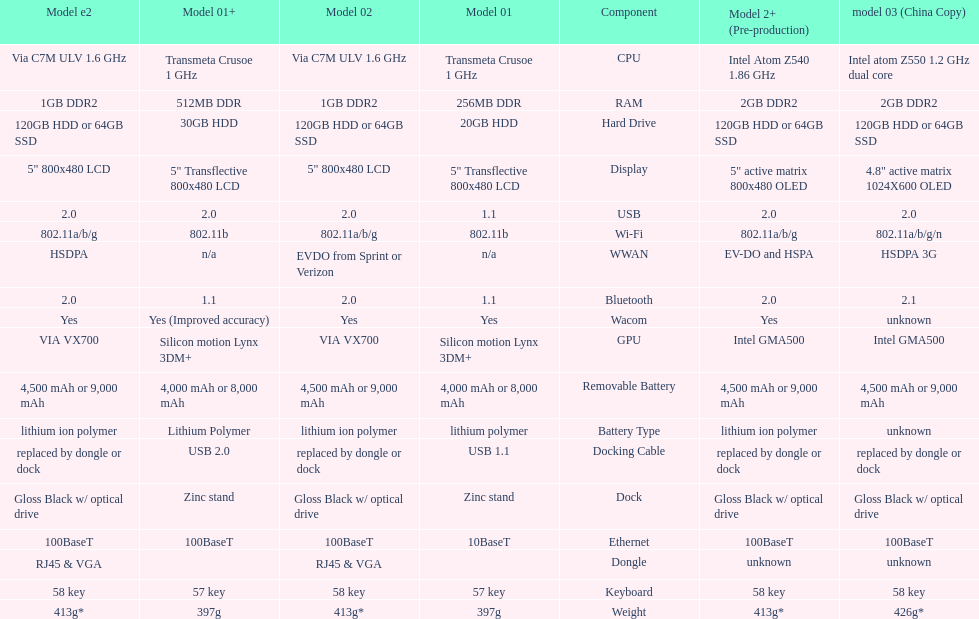Would you be able to parse every entry in this table? {'header': ['Model e2', 'Model 01+', 'Model 02', 'Model 01', 'Component', 'Model 2+ (Pre-production)', 'model 03 (China Copy)'], 'rows': [['Via C7M ULV 1.6\xa0GHz', 'Transmeta Crusoe 1\xa0GHz', 'Via C7M ULV 1.6\xa0GHz', 'Transmeta Crusoe 1\xa0GHz', 'CPU', 'Intel Atom Z540 1.86\xa0GHz', 'Intel atom Z550 1.2\xa0GHz dual core'], ['1GB DDR2', '512MB DDR', '1GB DDR2', '256MB DDR', 'RAM', '2GB DDR2', '2GB DDR2'], ['120GB HDD or 64GB SSD', '30GB HDD', '120GB HDD or 64GB SSD', '20GB HDD', 'Hard Drive', '120GB HDD or 64GB SSD', '120GB HDD or 64GB SSD'], ['5" 800x480 LCD', '5" Transflective 800x480 LCD', '5" 800x480 LCD', '5" Transflective 800x480 LCD', 'Display', '5" active matrix 800x480 OLED', '4.8" active matrix 1024X600 OLED'], ['2.0', '2.0', '2.0', '1.1', 'USB', '2.0', '2.0'], ['802.11a/b/g', '802.11b', '802.11a/b/g', '802.11b', 'Wi-Fi', '802.11a/b/g', '802.11a/b/g/n'], ['HSDPA', 'n/a', 'EVDO from Sprint or Verizon', 'n/a', 'WWAN', 'EV-DO and HSPA', 'HSDPA 3G'], ['2.0', '1.1', '2.0', '1.1', 'Bluetooth', '2.0', '2.1'], ['Yes', 'Yes (Improved accuracy)', 'Yes', 'Yes', 'Wacom', 'Yes', 'unknown'], ['VIA VX700', 'Silicon motion Lynx 3DM+', 'VIA VX700', 'Silicon motion Lynx 3DM+', 'GPU', 'Intel GMA500', 'Intel GMA500'], ['4,500 mAh or 9,000 mAh', '4,000 mAh or 8,000 mAh', '4,500 mAh or 9,000 mAh', '4,000 mAh or 8,000 mAh', 'Removable Battery', '4,500 mAh or 9,000 mAh', '4,500 mAh or 9,000 mAh'], ['lithium ion polymer', 'Lithium Polymer', 'lithium ion polymer', 'lithium polymer', 'Battery Type', 'lithium ion polymer', 'unknown'], ['replaced by dongle or dock', 'USB 2.0', 'replaced by dongle or dock', 'USB 1.1', 'Docking Cable', 'replaced by dongle or dock', 'replaced by dongle or dock'], ['Gloss Black w/ optical drive', 'Zinc stand', 'Gloss Black w/ optical drive', 'Zinc stand', 'Dock', 'Gloss Black w/ optical drive', 'Gloss Black w/ optical drive'], ['100BaseT', '100BaseT', '100BaseT', '10BaseT', 'Ethernet', '100BaseT', '100BaseT'], ['RJ45 & VGA', '', 'RJ45 & VGA', '', 'Dongle', 'unknown', 'unknown'], ['58 key', '57 key', '58 key', '57 key', 'Keyboard', '58 key', '58 key'], ['413g*', '397g', '413g*', '397g', 'Weight', '413g*', '426g*']]} How many models use a usb docking cable? 2. 